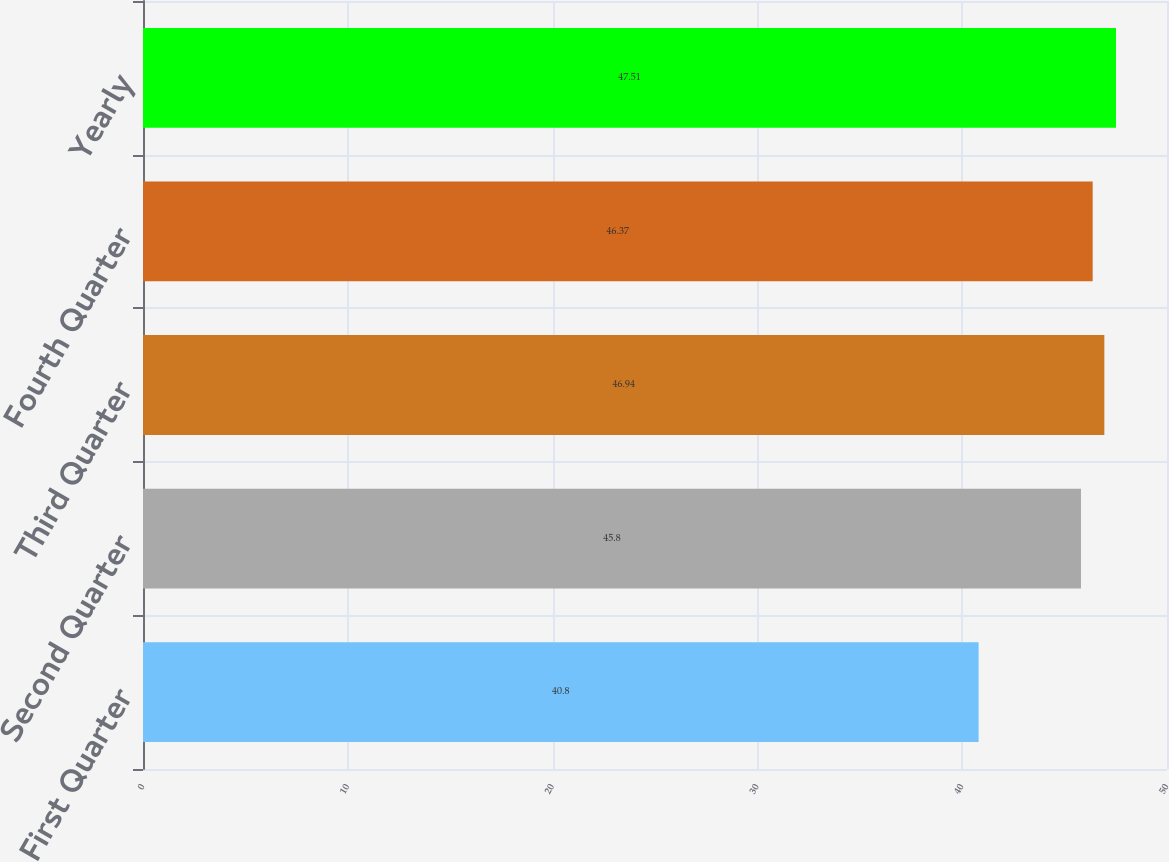Convert chart. <chart><loc_0><loc_0><loc_500><loc_500><bar_chart><fcel>First Quarter<fcel>Second Quarter<fcel>Third Quarter<fcel>Fourth Quarter<fcel>Yearly<nl><fcel>40.8<fcel>45.8<fcel>46.94<fcel>46.37<fcel>47.51<nl></chart> 